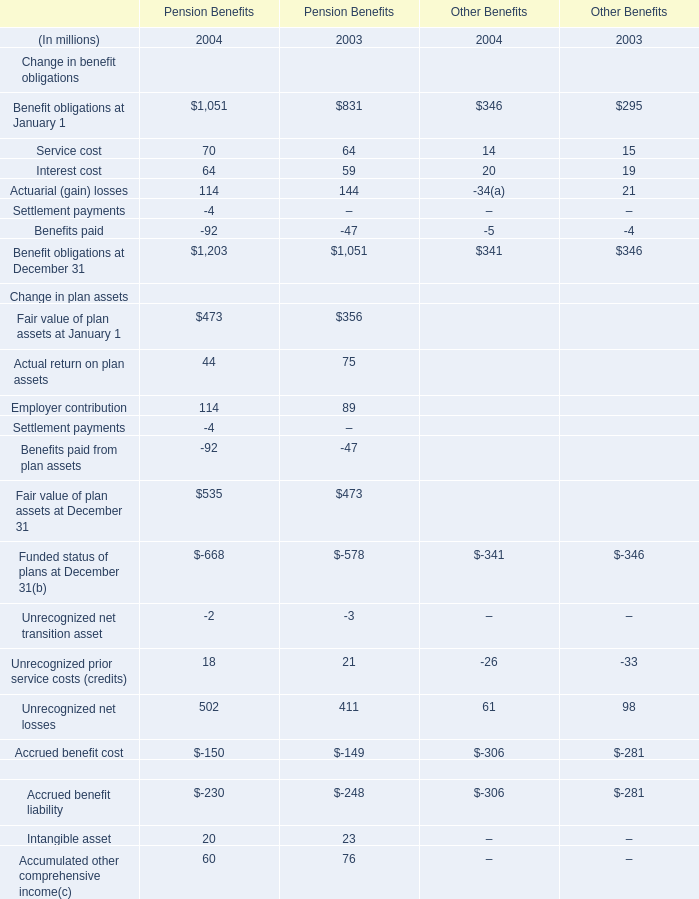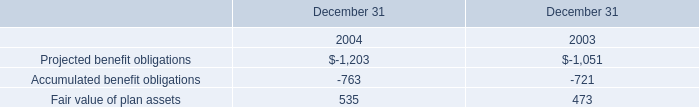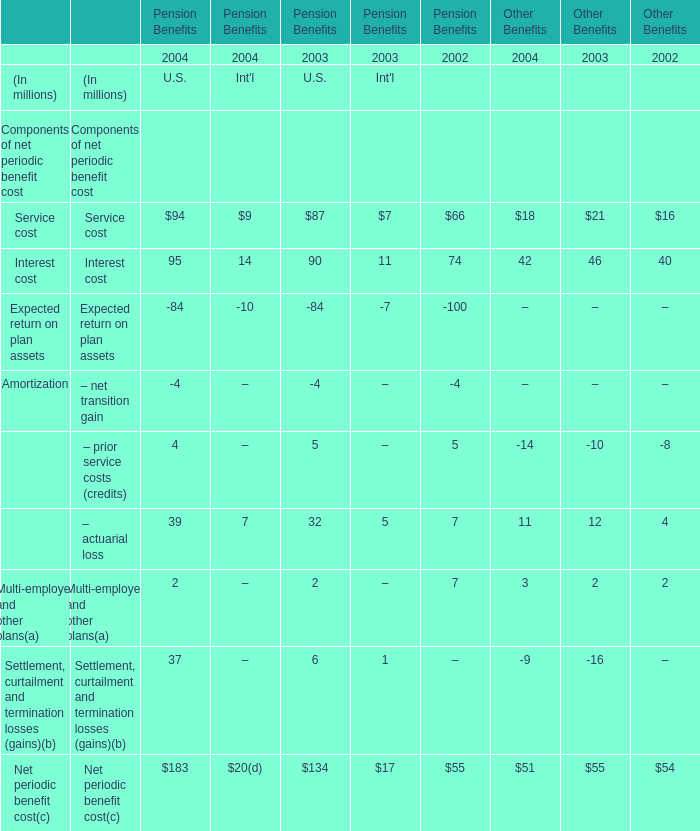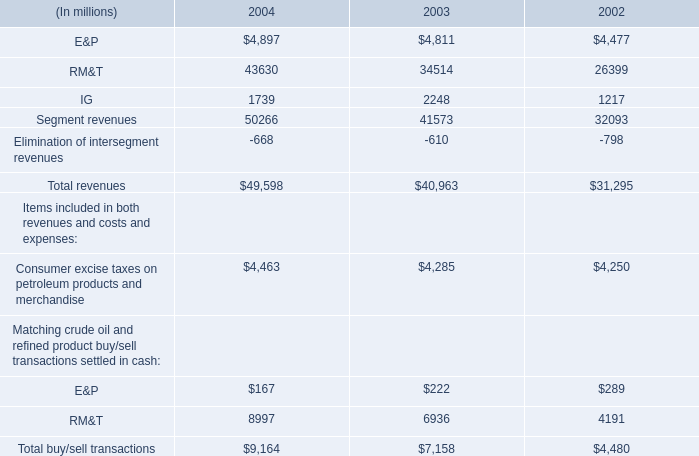what is the anticipated percentage increase in the berths for the european cruise market from 2013 to 2017 
Computations: (25000 / 156000)
Answer: 0.16026. 